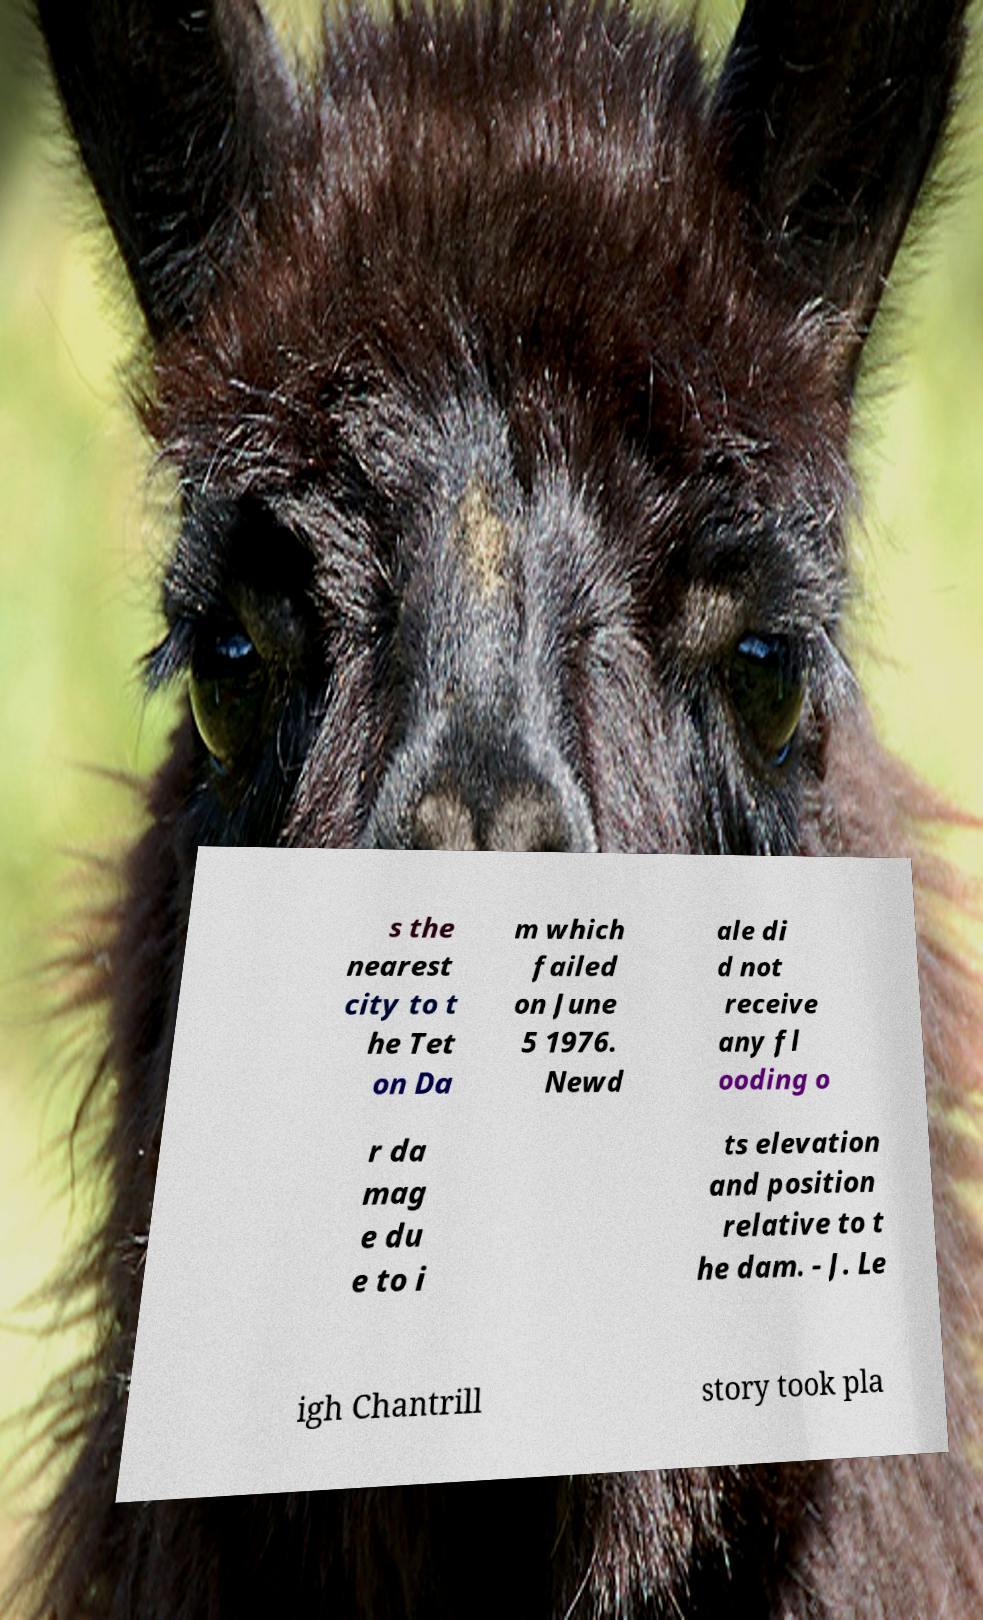Could you assist in decoding the text presented in this image and type it out clearly? s the nearest city to t he Tet on Da m which failed on June 5 1976. Newd ale di d not receive any fl ooding o r da mag e du e to i ts elevation and position relative to t he dam. - J. Le igh Chantrill story took pla 